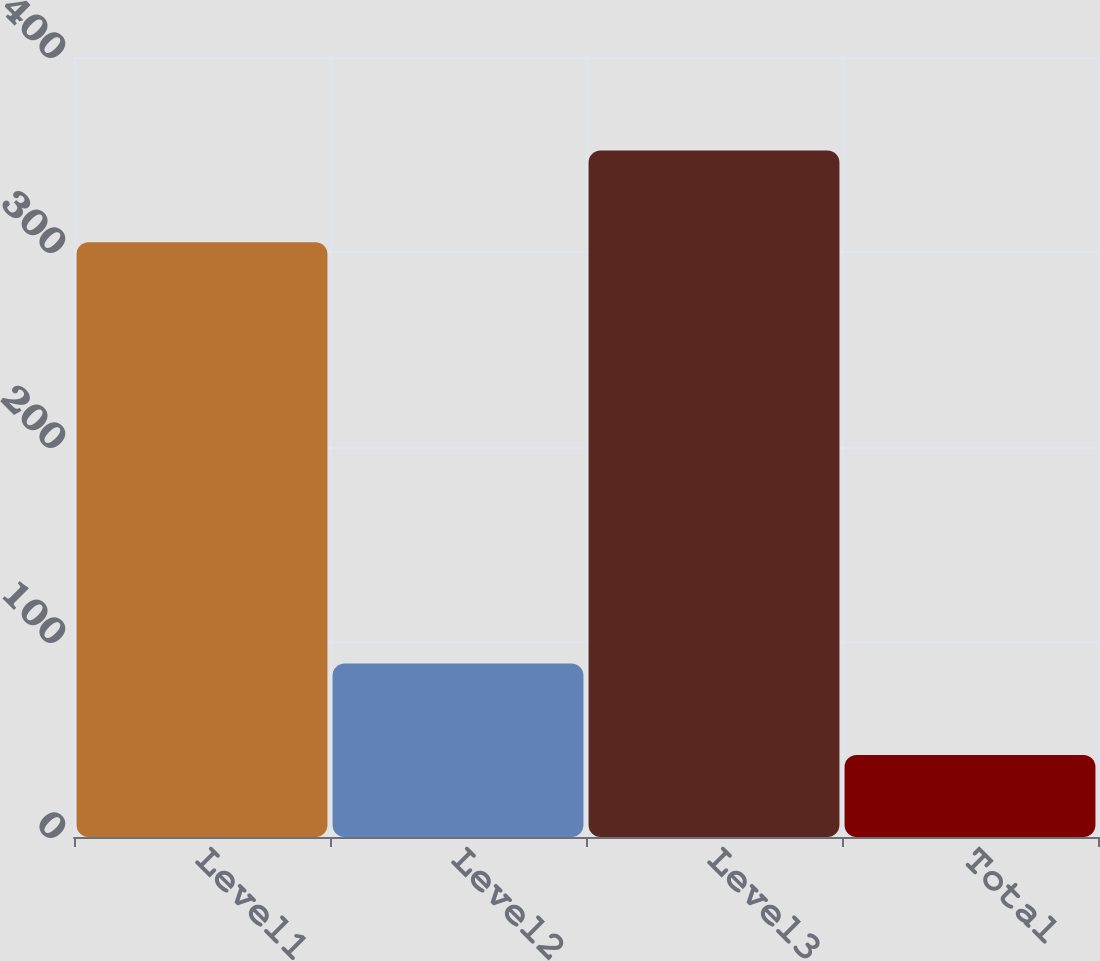Convert chart to OTSL. <chart><loc_0><loc_0><loc_500><loc_500><bar_chart><fcel>Level1<fcel>Level2<fcel>Level3<fcel>Total<nl><fcel>305<fcel>89<fcel>352<fcel>42<nl></chart> 